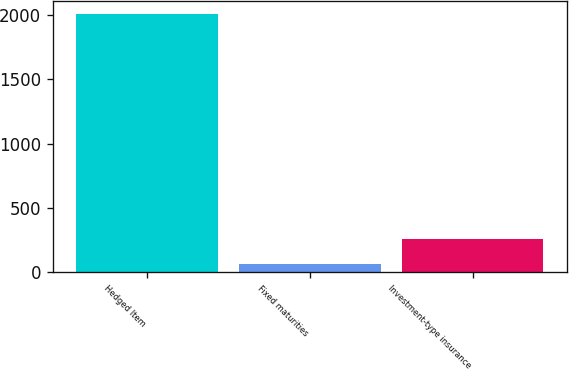<chart> <loc_0><loc_0><loc_500><loc_500><bar_chart><fcel>Hedged Item<fcel>Fixed maturities<fcel>Investment-type insurance<nl><fcel>2008<fcel>63.4<fcel>257.86<nl></chart> 